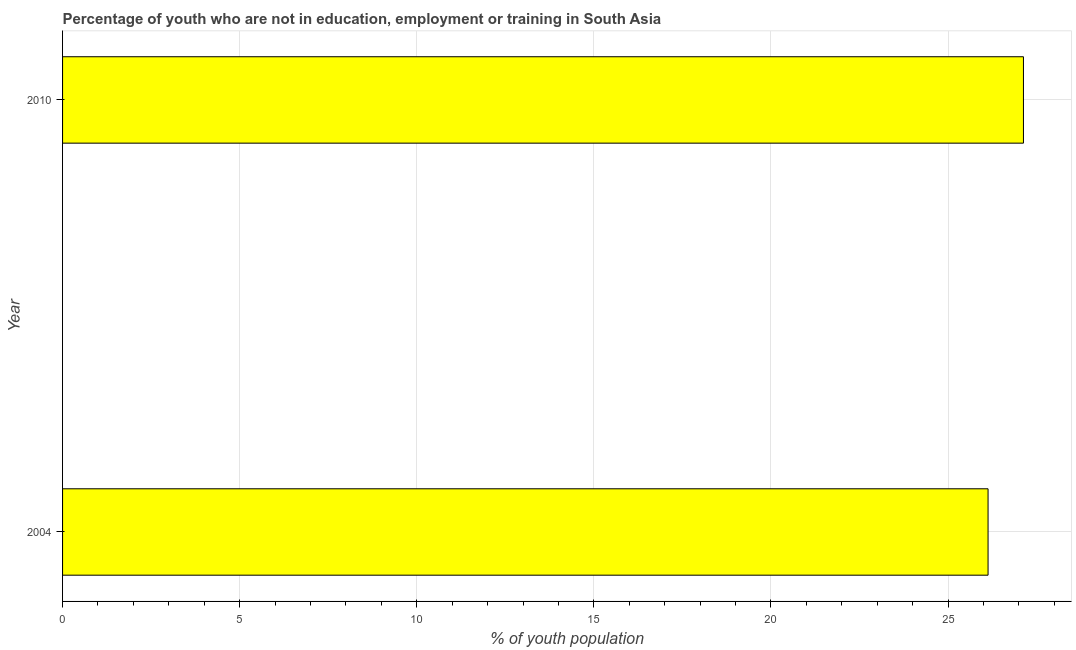Does the graph contain any zero values?
Your response must be concise. No. Does the graph contain grids?
Offer a terse response. Yes. What is the title of the graph?
Make the answer very short. Percentage of youth who are not in education, employment or training in South Asia. What is the label or title of the X-axis?
Provide a short and direct response. % of youth population. What is the label or title of the Y-axis?
Provide a succinct answer. Year. What is the unemployed youth population in 2004?
Your response must be concise. 26.13. Across all years, what is the maximum unemployed youth population?
Your response must be concise. 27.13. Across all years, what is the minimum unemployed youth population?
Your answer should be compact. 26.13. In which year was the unemployed youth population minimum?
Provide a short and direct response. 2004. What is the sum of the unemployed youth population?
Ensure brevity in your answer.  53.26. What is the difference between the unemployed youth population in 2004 and 2010?
Ensure brevity in your answer.  -1. What is the average unemployed youth population per year?
Your answer should be very brief. 26.63. What is the median unemployed youth population?
Ensure brevity in your answer.  26.63. What is the ratio of the unemployed youth population in 2004 to that in 2010?
Provide a succinct answer. 0.96. In how many years, is the unemployed youth population greater than the average unemployed youth population taken over all years?
Offer a terse response. 1. Are all the bars in the graph horizontal?
Your answer should be very brief. Yes. Are the values on the major ticks of X-axis written in scientific E-notation?
Provide a short and direct response. No. What is the % of youth population in 2004?
Offer a very short reply. 26.13. What is the % of youth population in 2010?
Ensure brevity in your answer.  27.13. What is the difference between the % of youth population in 2004 and 2010?
Ensure brevity in your answer.  -1. 